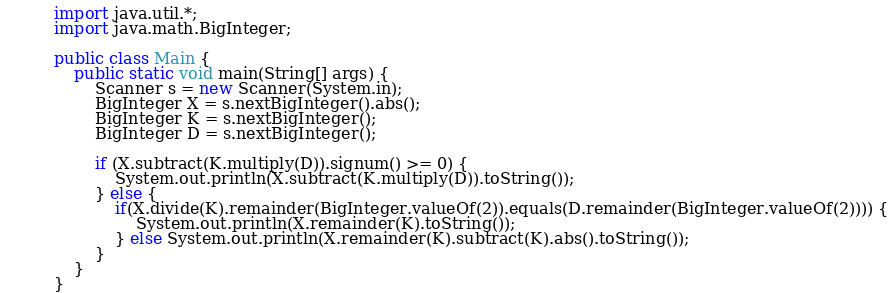<code> <loc_0><loc_0><loc_500><loc_500><_Java_>import java.util.*;
import java.math.BigInteger;

public class Main {
    public static void main(String[] args) {
        Scanner s = new Scanner(System.in);
        BigInteger X = s.nextBigInteger().abs();
        BigInteger K = s.nextBigInteger();
        BigInteger D = s.nextBigInteger();

        if (X.subtract(K.multiply(D)).signum() >= 0) {
            System.out.println(X.subtract(K.multiply(D)).toString());
        } else {
            if(X.divide(K).remainder(BigInteger.valueOf(2)).equals(D.remainder(BigInteger.valueOf(2)))) {
                System.out.println(X.remainder(K).toString());
            } else System.out.println(X.remainder(K).subtract(K).abs().toString());
        }
    }
}</code> 